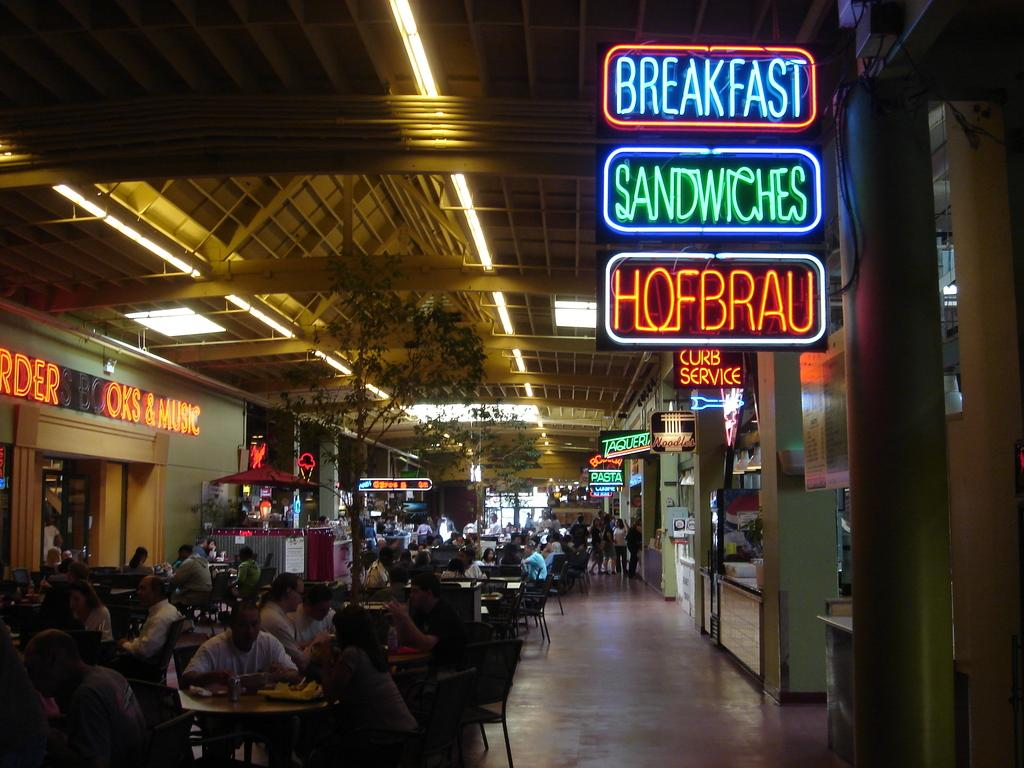Who or what can be seen in the image? There are people in the image. What type of furniture is present in the image? There are tables and chairs in the image. Are there any written words visible in the image? Yes, there are walls with text written on them in the image. What can be seen at the top of the image? There are lights visible at the top of the image. What type of beef is being served at the event in the image? There is no beef or event present in the image; it only shows people, tables, chairs, walls with text, and lights. How does the yak feel about the situation depicted in the image? There is no yak present in the image, so it is impossible to determine its feelings. 